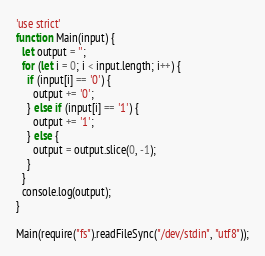Convert code to text. <code><loc_0><loc_0><loc_500><loc_500><_JavaScript_>'use strict'
function Main(input) {
  let output = '';
  for (let i = 0; i < input.length; i++) {
    if (input[i] == '0') {
      output += '0';
    } else if (input[i] == '1') {
      output += '1';
    } else {
      output = output.slice(0, -1);
    }
  }
  console.log(output);
}

Main(require("fs").readFileSync("/dev/stdin", "utf8"));</code> 